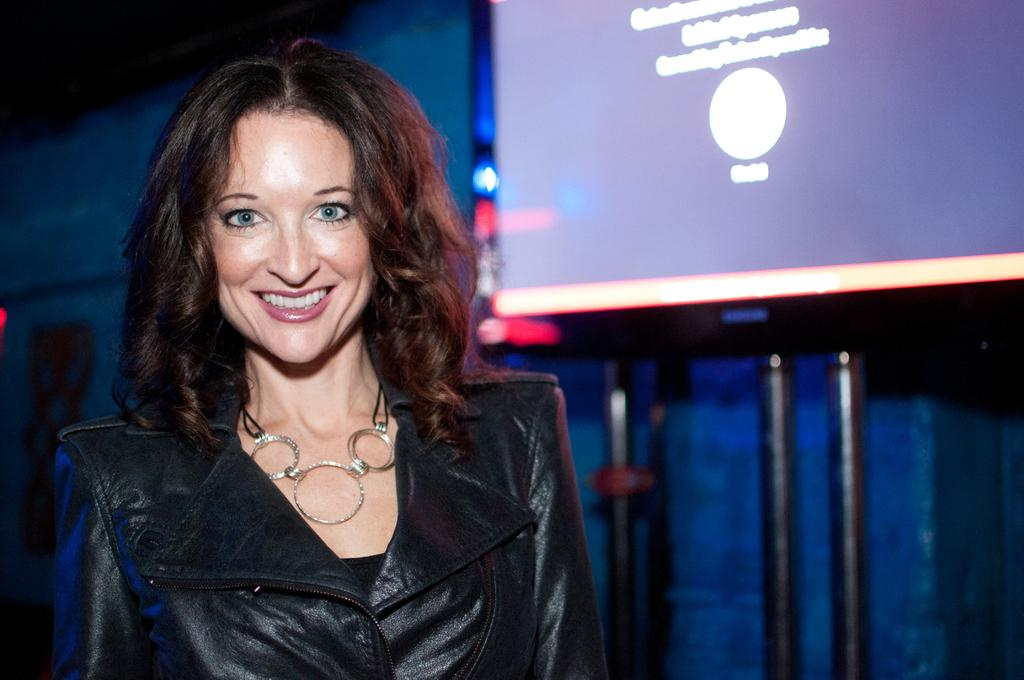What is the main subject of the image? The main subject of the image is a woman. Can you describe the woman's attire? The woman is wearing a black dress. What is the woman doing in the image? The woman is standing and smiling. What can be seen in the background of the image? There is a wall in the background of the image, and on the wall, there is a screen with poles under it. How does the woman wash her clothes in the image? There is no indication in the image that the woman is washing clothes, as she is wearing a black dress and standing near a wall with a screen and poles. What type of plastic object can be seen in the image? There is no plastic object present in the image. 